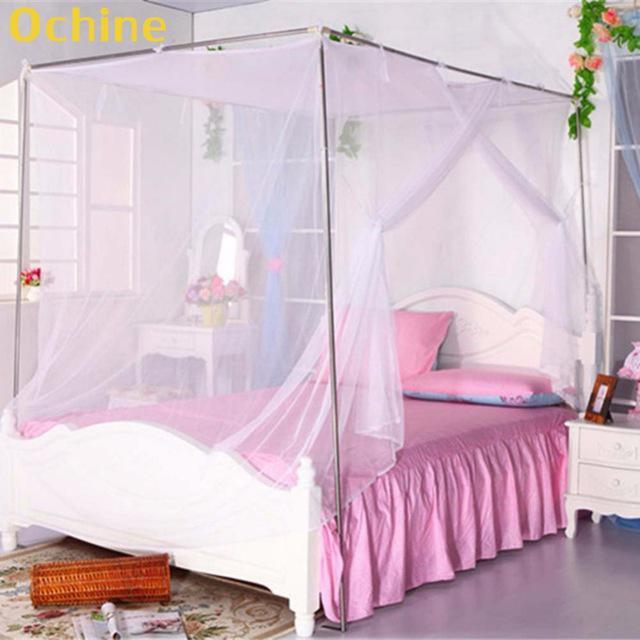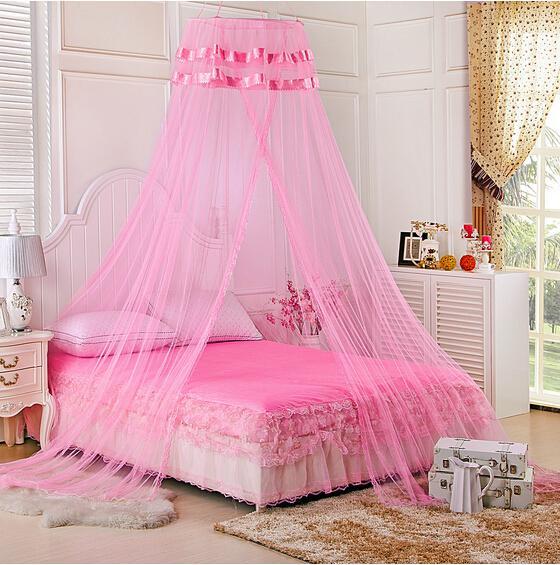The first image is the image on the left, the second image is the image on the right. For the images shown, is this caption "The bed on the left has a canopy that ties at the middle of the four posts, and the bed on the right has a pale canopy that creates a square shape but does not tie at the corners." true? Answer yes or no. No. The first image is the image on the left, the second image is the image on the right. Given the left and right images, does the statement "The left and right image contains the same number of square lace canopies." hold true? Answer yes or no. No. 